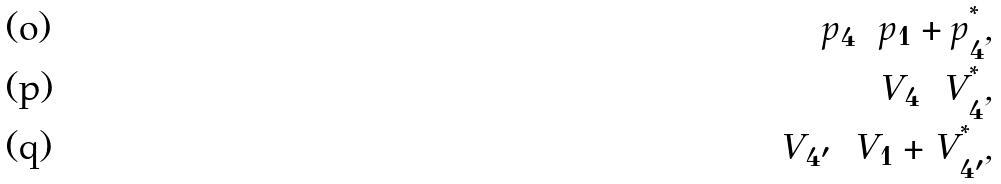Convert formula to latex. <formula><loc_0><loc_0><loc_500><loc_500>p _ { 4 } = p _ { 1 } + p _ { 4 } ^ { ^ { * } } , \\ V _ { 4 } = V _ { 4 } ^ { ^ { * } } , \\ V _ { 4 ^ { \prime } } = V _ { 1 } + V _ { 4 ^ { \prime } } ^ { ^ { * } } ,</formula> 